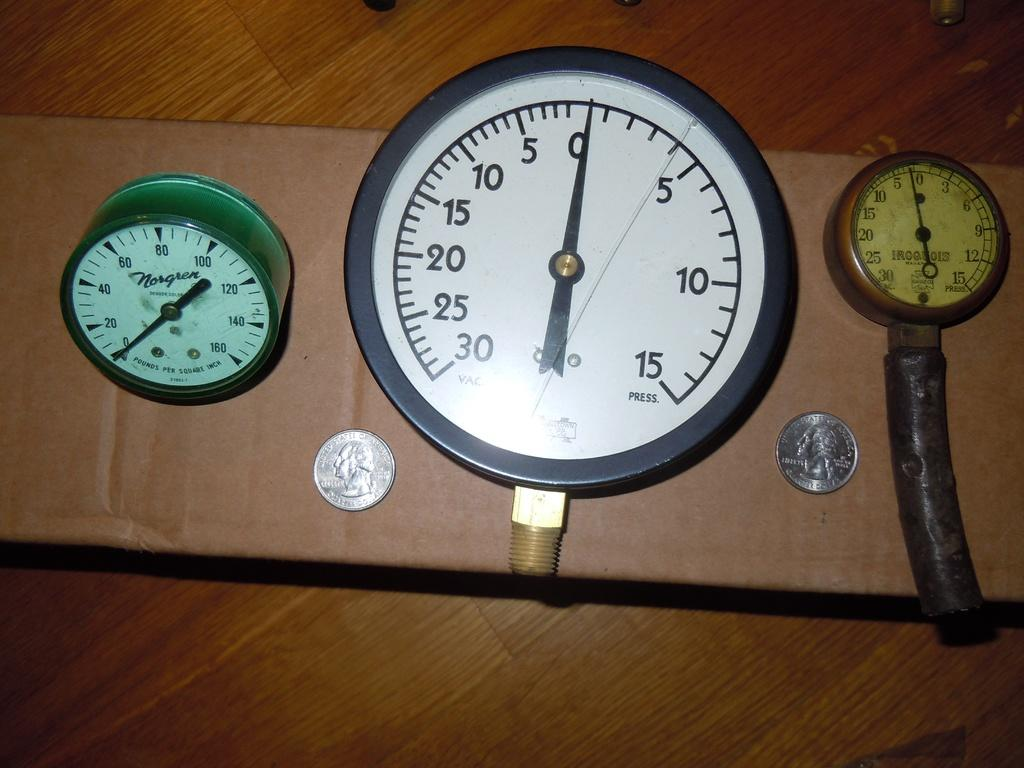<image>
Summarize the visual content of the image. Three different types of timer clocks with two quarters 